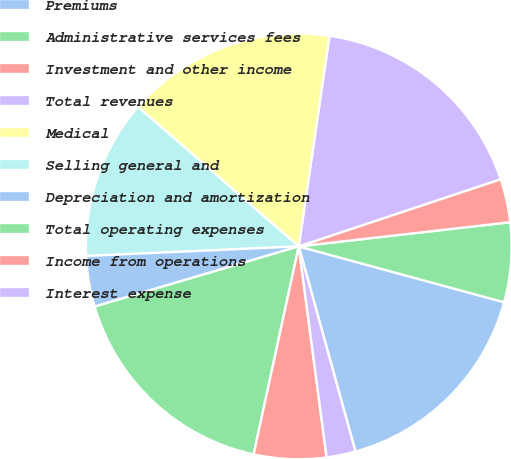<chart> <loc_0><loc_0><loc_500><loc_500><pie_chart><fcel>Premiums<fcel>Administrative services fees<fcel>Investment and other income<fcel>Total revenues<fcel>Medical<fcel>Selling general and<fcel>Depreciation and amortization<fcel>Total operating expenses<fcel>Income from operations<fcel>Interest expense<nl><fcel>16.48%<fcel>6.04%<fcel>3.3%<fcel>17.58%<fcel>15.93%<fcel>12.09%<fcel>3.85%<fcel>17.03%<fcel>5.49%<fcel>2.2%<nl></chart> 